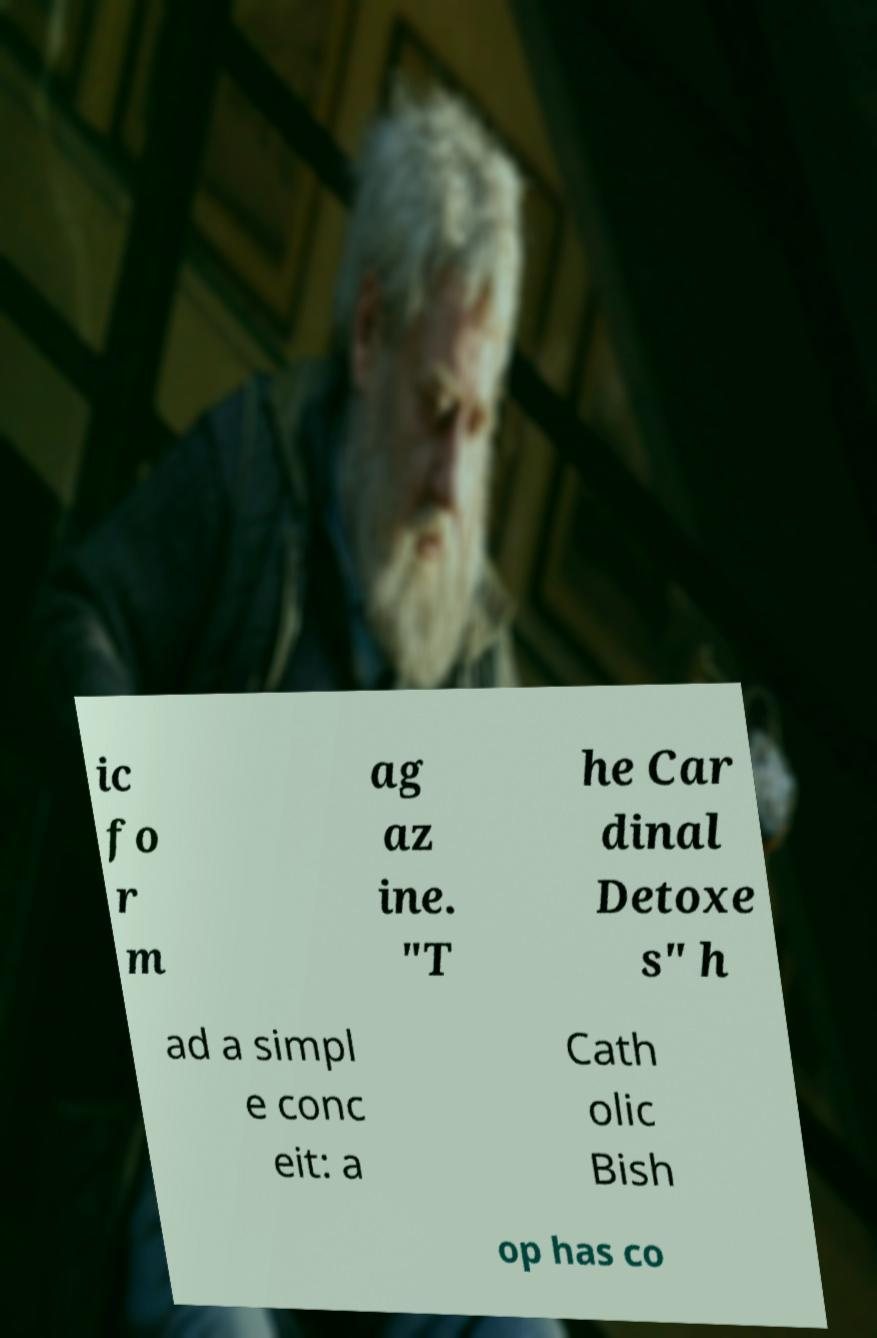Could you assist in decoding the text presented in this image and type it out clearly? ic fo r m ag az ine. "T he Car dinal Detoxe s" h ad a simpl e conc eit: a Cath olic Bish op has co 